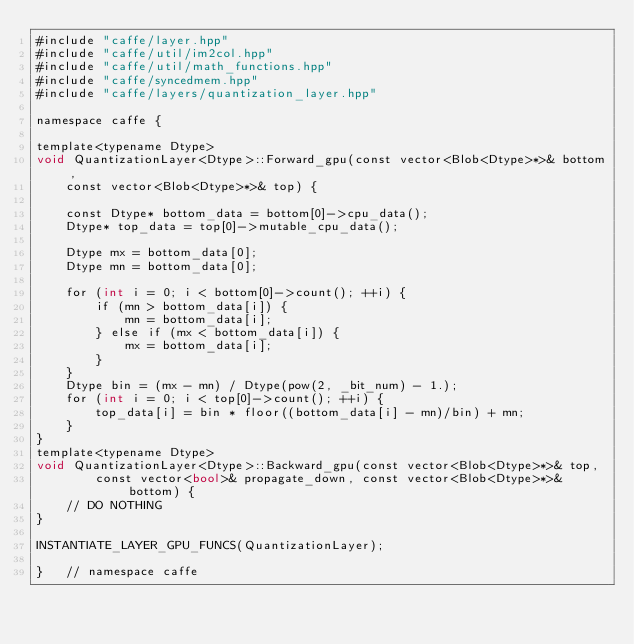Convert code to text. <code><loc_0><loc_0><loc_500><loc_500><_Cuda_>#include "caffe/layer.hpp"
#include "caffe/util/im2col.hpp"
#include "caffe/util/math_functions.hpp"
#include "caffe/syncedmem.hpp"
#include "caffe/layers/quantization_layer.hpp"

namespace caffe {

template<typename Dtype>
void QuantizationLayer<Dtype>::Forward_gpu(const vector<Blob<Dtype>*>& bottom, 
	const vector<Blob<Dtype>*>& top) {

	const Dtype* bottom_data = bottom[0]->cpu_data();
	Dtype* top_data = top[0]->mutable_cpu_data();
	
	Dtype mx = bottom_data[0];
	Dtype mn = bottom_data[0];

	for (int i = 0; i < bottom[0]->count(); ++i) {
		if (mn > bottom_data[i]) {
			mn = bottom_data[i];
		} else if (mx < bottom_data[i]) {
			mx = bottom_data[i];
		}
	}
	Dtype bin = (mx - mn) / Dtype(pow(2, _bit_num) - 1.);
	for (int i = 0; i < top[0]->count(); ++i) {
		top_data[i] = bin * floor((bottom_data[i] - mn)/bin) + mn;
	}
}
template<typename Dtype>
void QuantizationLayer<Dtype>::Backward_gpu(const vector<Blob<Dtype>*>& top,
        const vector<bool>& propagate_down, const vector<Blob<Dtype>*>& bottom) {
    // DO NOTHING
}

INSTANTIATE_LAYER_GPU_FUNCS(QuantizationLayer);

}	// namespace caffe</code> 